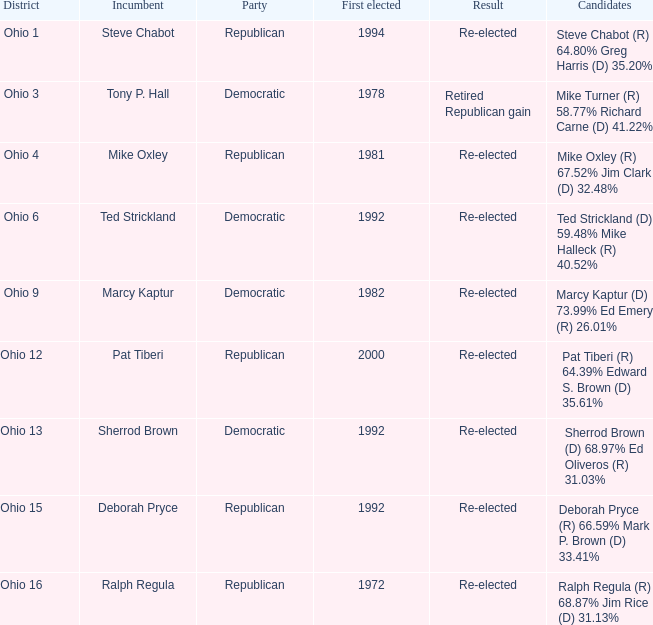In what district was the incumbent Steve Chabot?  Ohio 1. 